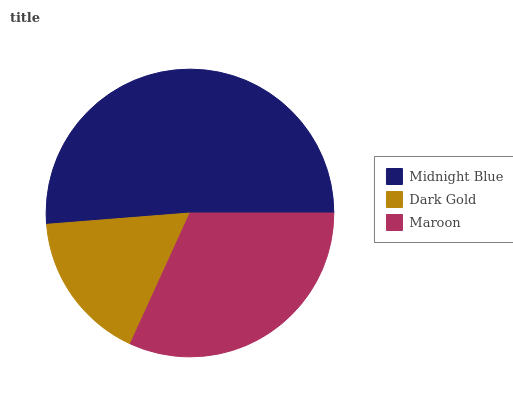Is Dark Gold the minimum?
Answer yes or no. Yes. Is Midnight Blue the maximum?
Answer yes or no. Yes. Is Maroon the minimum?
Answer yes or no. No. Is Maroon the maximum?
Answer yes or no. No. Is Maroon greater than Dark Gold?
Answer yes or no. Yes. Is Dark Gold less than Maroon?
Answer yes or no. Yes. Is Dark Gold greater than Maroon?
Answer yes or no. No. Is Maroon less than Dark Gold?
Answer yes or no. No. Is Maroon the high median?
Answer yes or no. Yes. Is Maroon the low median?
Answer yes or no. Yes. Is Dark Gold the high median?
Answer yes or no. No. Is Dark Gold the low median?
Answer yes or no. No. 